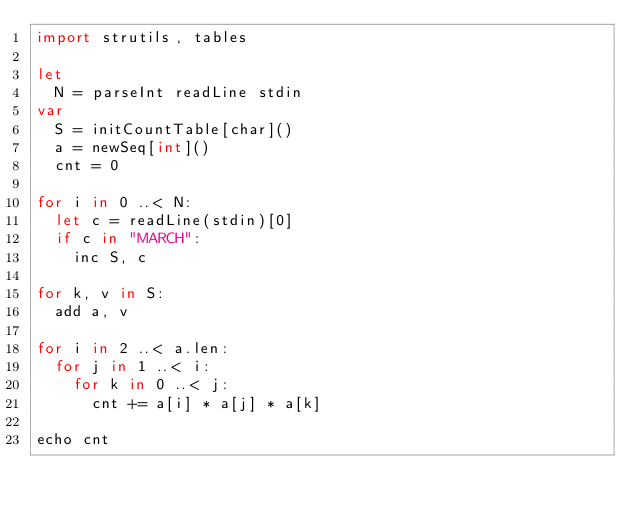<code> <loc_0><loc_0><loc_500><loc_500><_Nim_>import strutils, tables

let
  N = parseInt readLine stdin
var
  S = initCountTable[char]()
  a = newSeq[int]()
  cnt = 0

for i in 0 ..< N:
  let c = readLine(stdin)[0]
  if c in "MARCH":
    inc S, c

for k, v in S:
  add a, v

for i in 2 ..< a.len:
  for j in 1 ..< i:
    for k in 0 ..< j:
      cnt += a[i] * a[j] * a[k]

echo cnt
</code> 